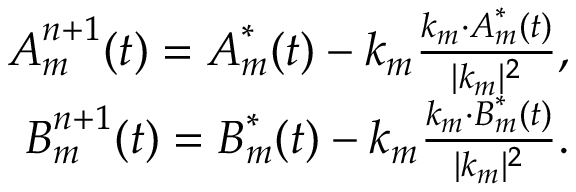Convert formula to latex. <formula><loc_0><loc_0><loc_500><loc_500>\begin{array} { r } { A _ { m } ^ { n + 1 } ( t ) = A _ { m } ^ { * } ( t ) - k _ { m } \frac { k _ { m } \cdot A _ { m } ^ { * } ( t ) } { | k _ { m } | ^ { 2 } } , } \\ { B _ { m } ^ { n + 1 } ( t ) = B _ { m } ^ { * } ( t ) - k _ { m } \frac { k _ { m } \cdot B _ { m } ^ { * } ( t ) } { | k _ { m } | ^ { 2 } } . } \end{array}</formula> 